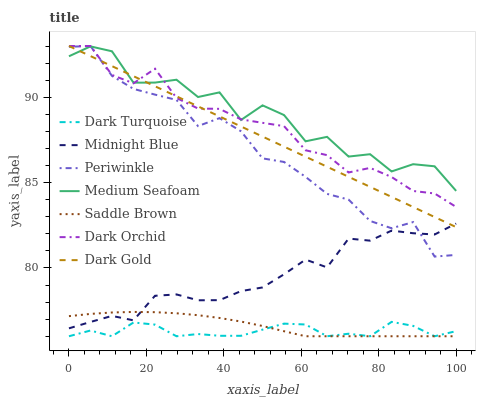Does Dark Turquoise have the minimum area under the curve?
Answer yes or no. Yes. Does Medium Seafoam have the maximum area under the curve?
Answer yes or no. Yes. Does Dark Gold have the minimum area under the curve?
Answer yes or no. No. Does Dark Gold have the maximum area under the curve?
Answer yes or no. No. Is Dark Gold the smoothest?
Answer yes or no. Yes. Is Medium Seafoam the roughest?
Answer yes or no. Yes. Is Dark Turquoise the smoothest?
Answer yes or no. No. Is Dark Turquoise the roughest?
Answer yes or no. No. Does Dark Turquoise have the lowest value?
Answer yes or no. Yes. Does Dark Gold have the lowest value?
Answer yes or no. No. Does Periwinkle have the highest value?
Answer yes or no. Yes. Does Dark Turquoise have the highest value?
Answer yes or no. No. Is Dark Turquoise less than Medium Seafoam?
Answer yes or no. Yes. Is Dark Orchid greater than Midnight Blue?
Answer yes or no. Yes. Does Dark Gold intersect Dark Orchid?
Answer yes or no. Yes. Is Dark Gold less than Dark Orchid?
Answer yes or no. No. Is Dark Gold greater than Dark Orchid?
Answer yes or no. No. Does Dark Turquoise intersect Medium Seafoam?
Answer yes or no. No. 